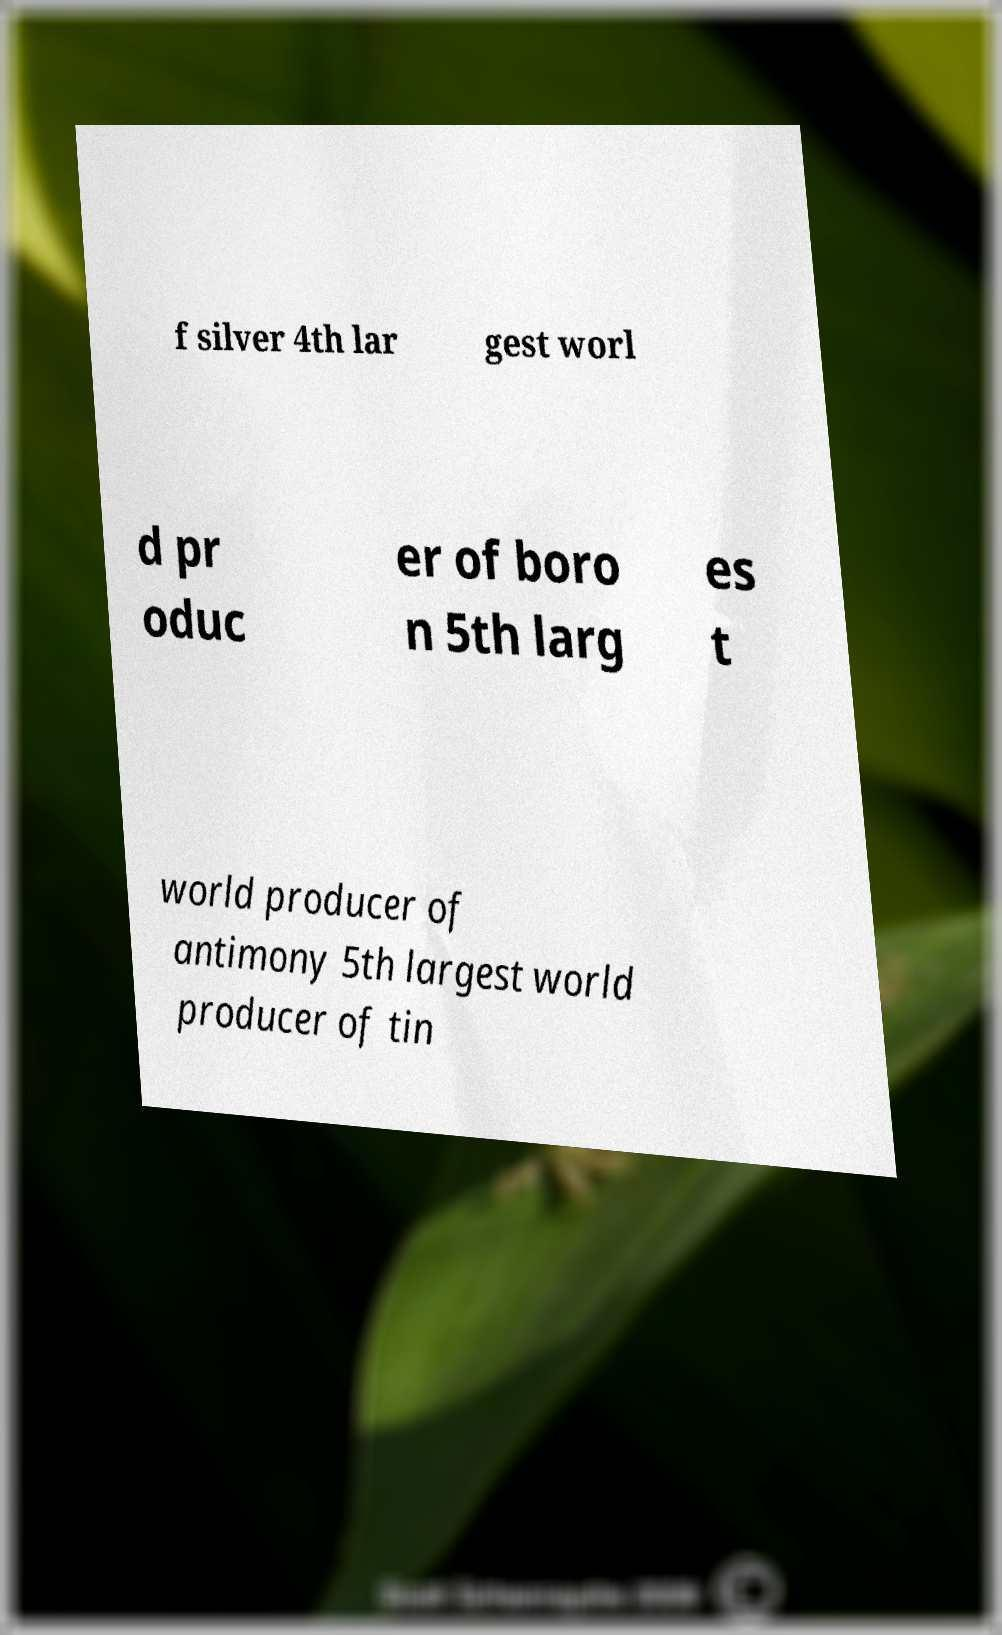Can you read and provide the text displayed in the image?This photo seems to have some interesting text. Can you extract and type it out for me? f silver 4th lar gest worl d pr oduc er of boro n 5th larg es t world producer of antimony 5th largest world producer of tin 